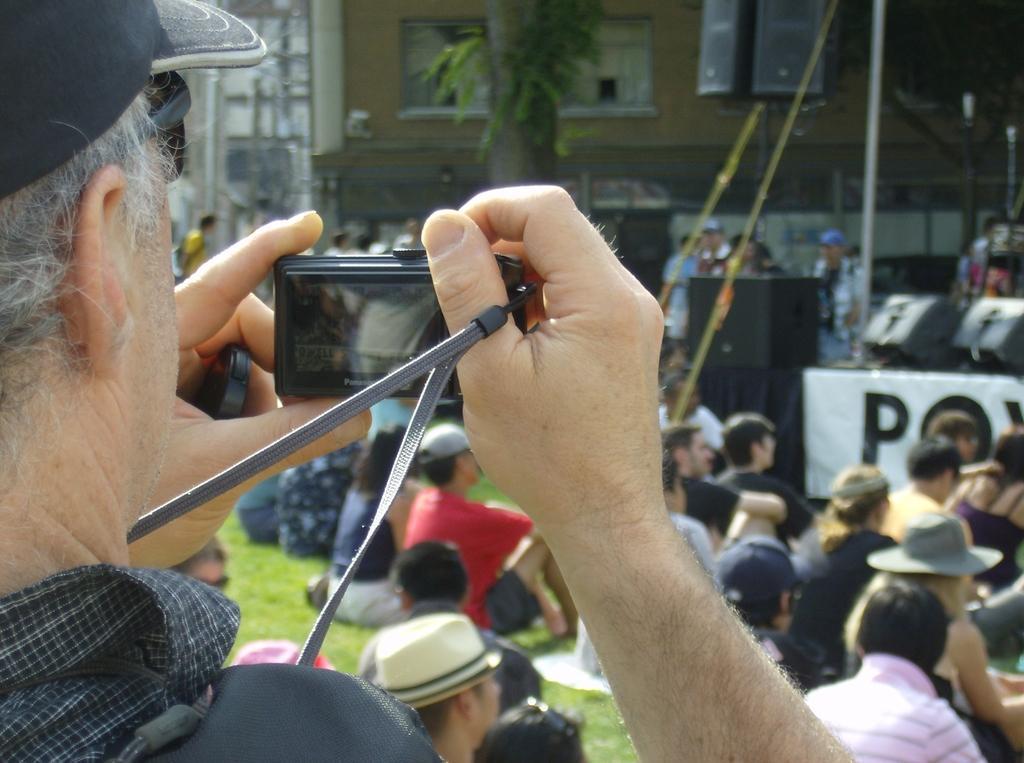How would you summarize this image in a sentence or two? In this image there is a person wearing a cap and goggles. He is holding a camera in hands. There are people sitting on the grassland. Right side there are objects. Behind there are people. Middle of the image there is a tree. Behind there are buildings. 